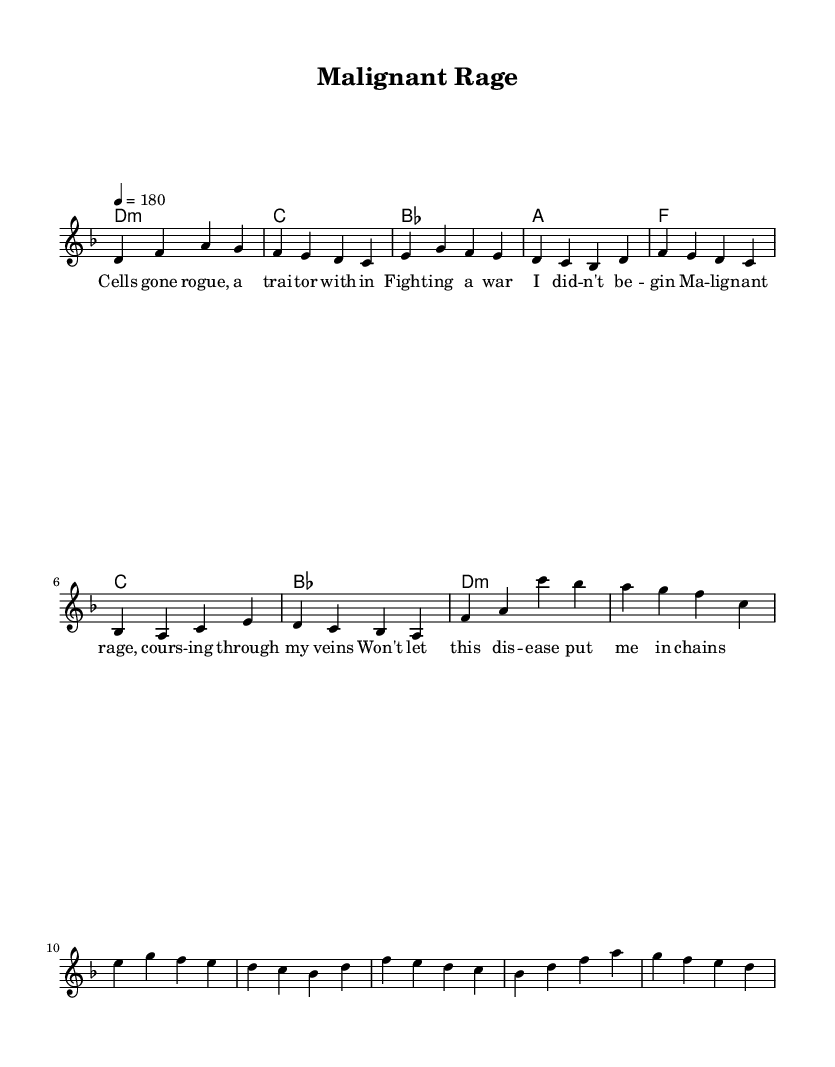What is the key signature of this music? The key signature is denoted by the 'd' in the global section of the code, which indicates that the piece is in D minor.
Answer: D minor What is the time signature of this music? The time signature is indicated in the global section as 4/4, which means there are four beats in each measure and the quarter note gets one beat.
Answer: 4/4 What is the tempo marking for this music? The tempo marking is given as "4 = 180", which means there are 180 beats per minute, suggesting a fast-paced performance characteristic of punk music.
Answer: 180 How many measures are in the verse? By analyzing the melody section, there are four lines of musical notation, each consisting of one measure, resulting in a total of four measures in the verse.
Answer: 4 What emotional theme does the lyrics convey? The lyrics are centered around the battle against a disease, expressing raw anger and frustration, typical of punk's emotional intensity.
Answer: Anger and frustration What type of chord progression is primarily used in the verse? The verse follows a simple chord progression of D minor, C major, B flat major, and A major, which is typical in punk for creating a raw, straightforward sound.
Answer: D minor, C, B flat, A What specific lyrical device is used in the chorus? The chorus features repetition of phrases and strong imagery of rage and chains, which amplifies emotional intensity and aligns with the punk genre's focus on personal struggles.
Answer: Repetition and strong imagery 